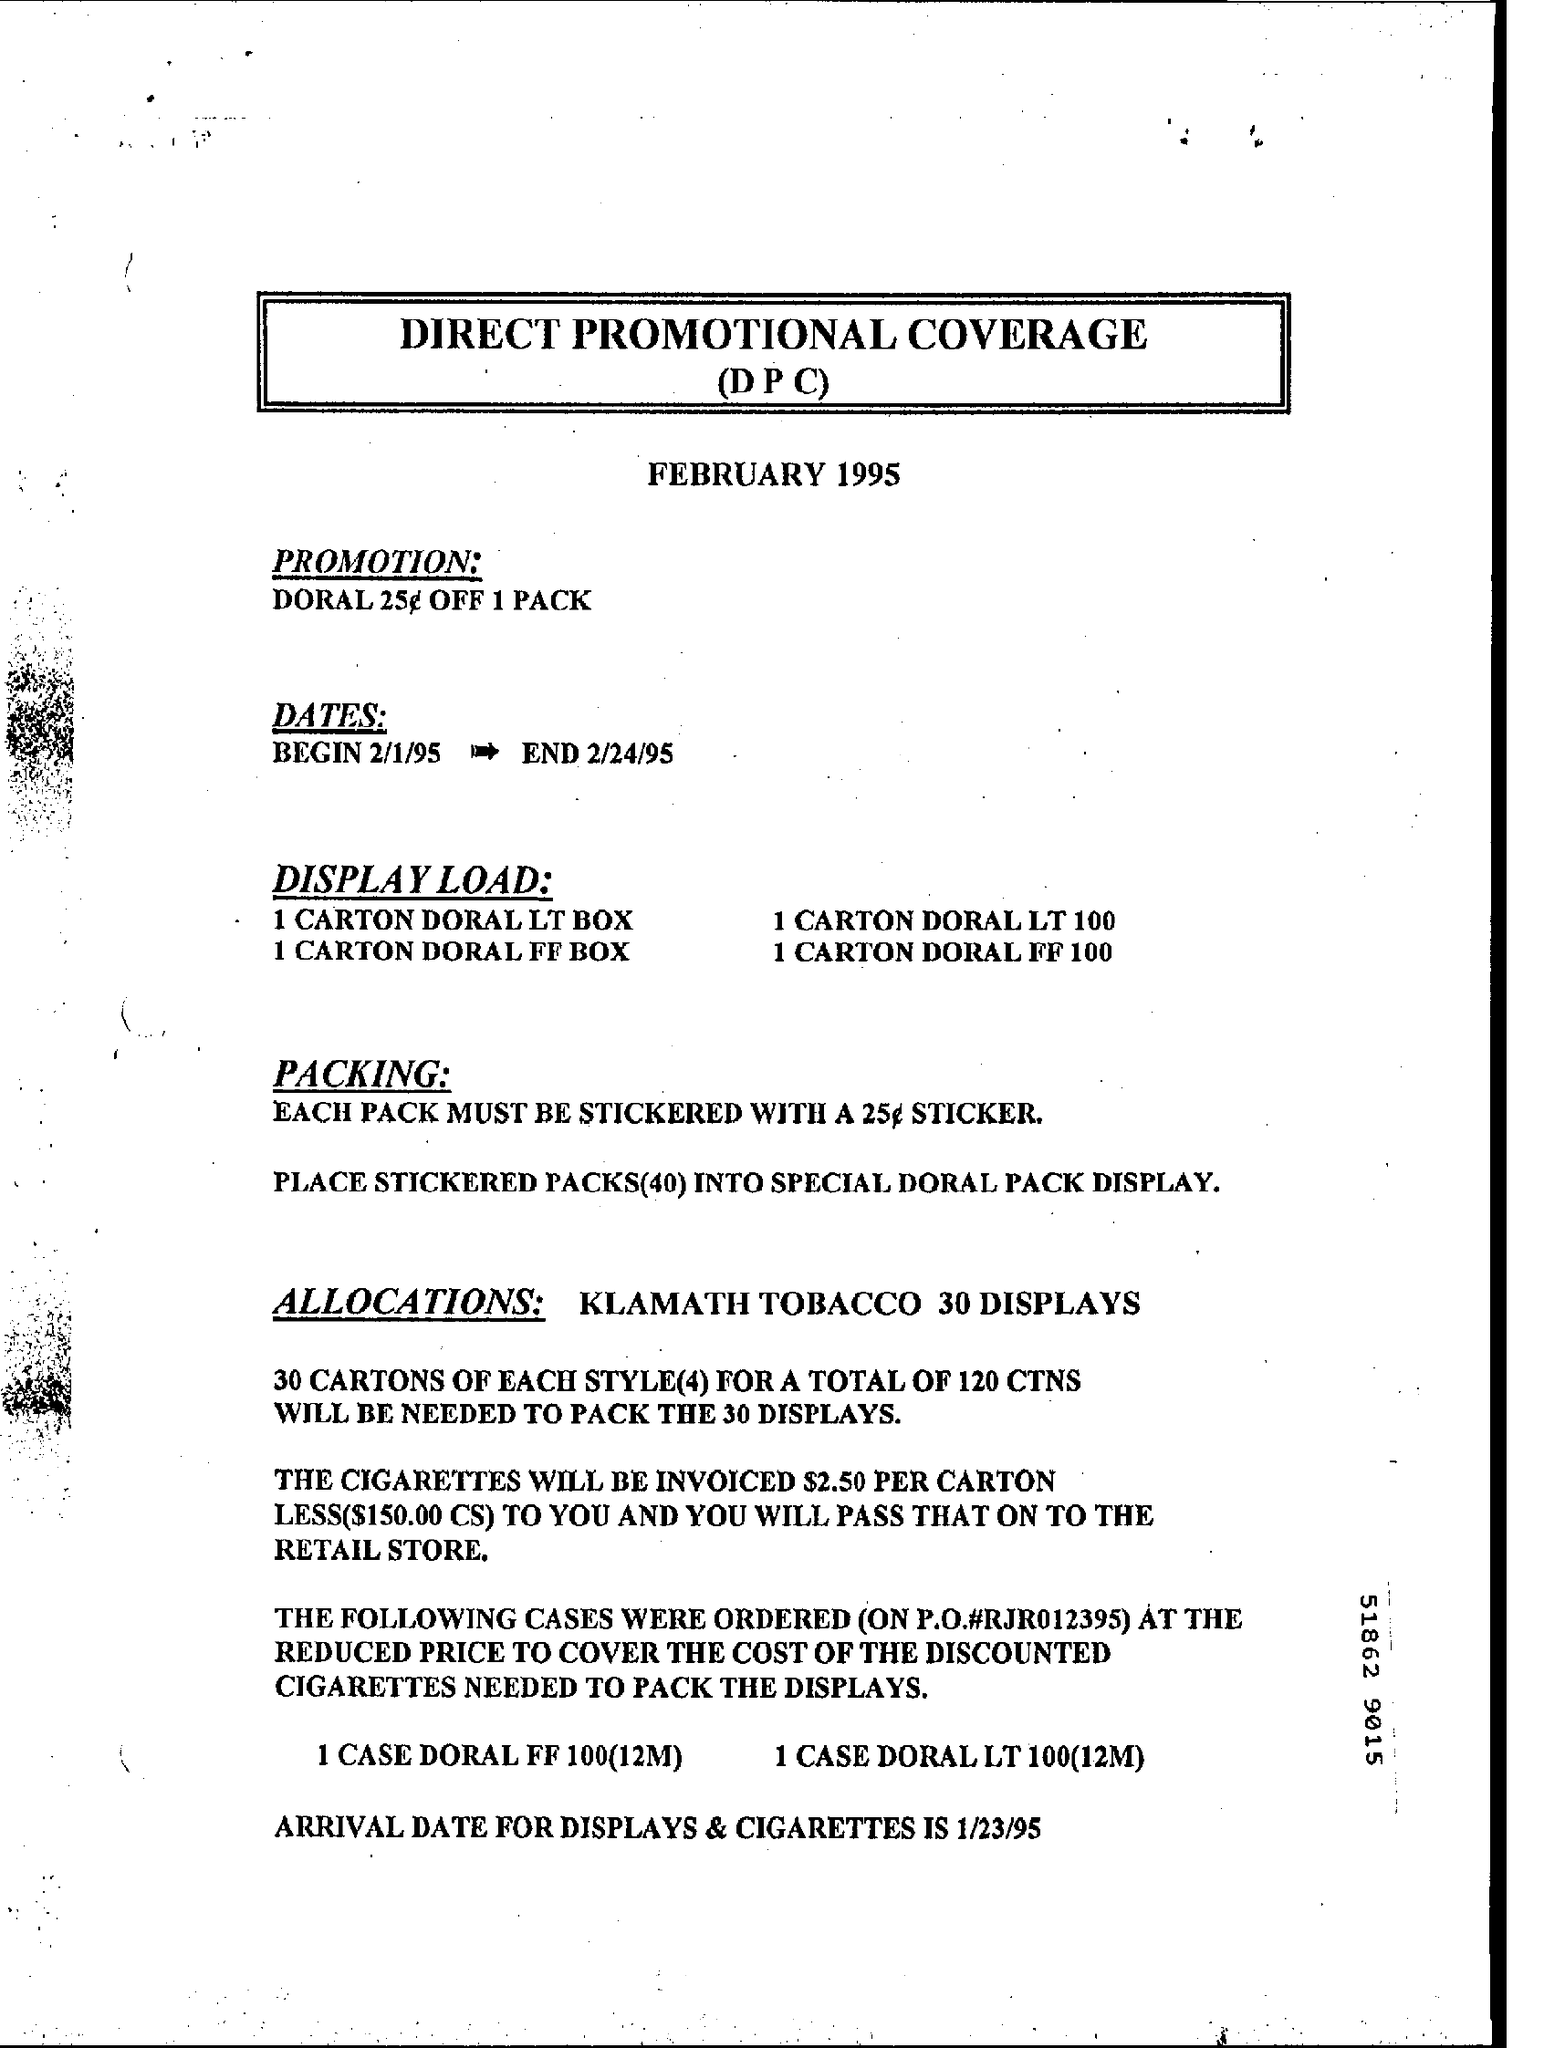Give some essential details in this illustration. The ending date is February 24, 1995. The beginning date is February 1, 1995. Direct Promotional Coverage (DPC) is a term that refers to the use of various marketing and advertising strategies to promote a product or service directly to the target audience. 